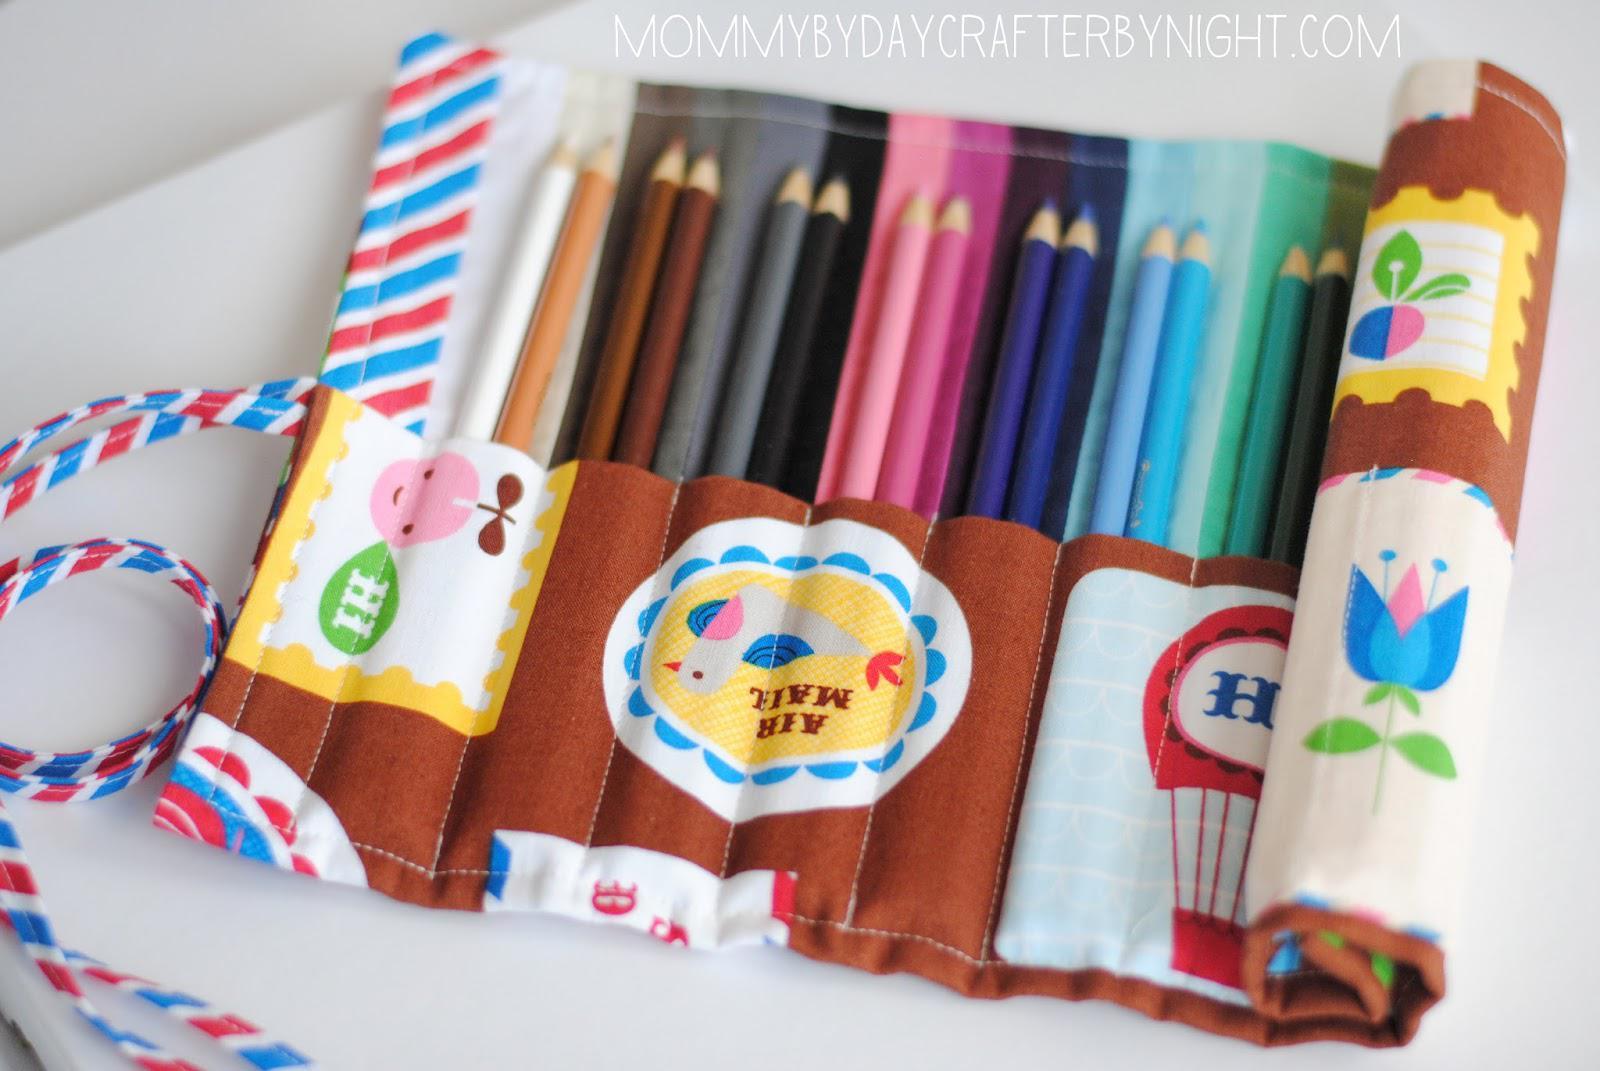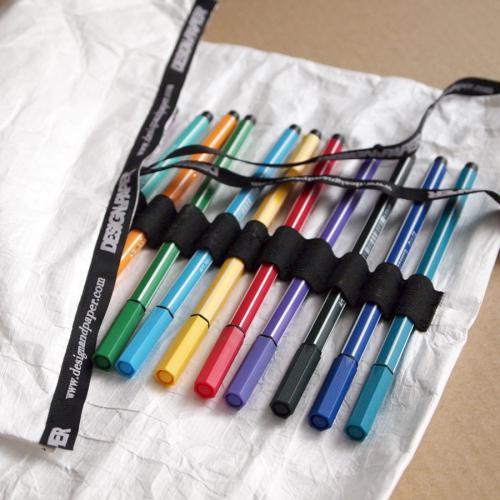The first image is the image on the left, the second image is the image on the right. Examine the images to the left and right. Is the description "In one image, a red plaid pencil case is unrolled, revealing a long red pocket that contains a collection of pencils, markers, pens, and a green frog eraser." accurate? Answer yes or no. No. The first image is the image on the left, the second image is the image on the right. Evaluate the accuracy of this statement regarding the images: "One image shows an unrolled pencil case with a solid red and tartan plaid interior, and the other shows a case with a small printed pattern on its interior.". Is it true? Answer yes or no. No. 